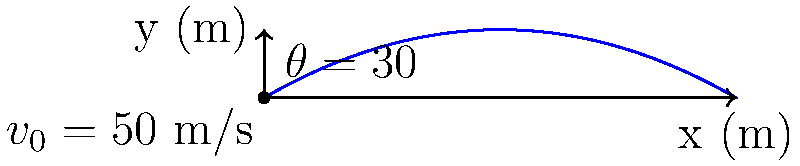A Portuguese coder is experimenting with a projectile motion simulator. In the simulation, a projectile is launched with an initial velocity of 50 m/s at an angle of 30° above the horizontal. Assuming no air resistance, calculate the maximum height reached by the projectile. Round your answer to the nearest tenth of a meter. To find the maximum height, we'll follow these steps:

1) The vertical component of the initial velocity is:
   $$v_{0y} = v_0 \sin(\theta) = 50 \sin(30°) = 25 \text{ m/s}$$

2) The time to reach the maximum height is when the vertical velocity becomes zero:
   $$0 = v_{0y} - gt$$
   $$t = \frac{v_{0y}}{g} = \frac{25}{9.8} = 2.55 \text{ s}$$

3) The maximum height can be calculated using the equation:
   $$y = v_{0y}t - \frac{1}{2}gt^2$$

4) Substituting the values:
   $$y = 25 * 2.55 - \frac{1}{2} * 9.8 * 2.55^2$$
   $$y = 63.75 - 31.88 = 31.87 \text{ m}$$

5) Rounding to the nearest tenth:
   $$y \approx 31.9 \text{ m}$$
Answer: 31.9 m 